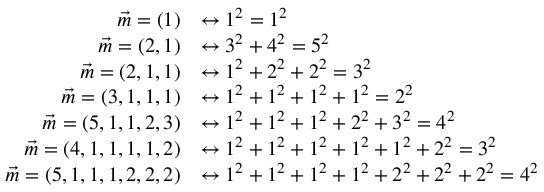Convert formula to latex. <formula><loc_0><loc_0><loc_500><loc_500>{ \begin{array} { r l } { { \vec { m } } = ( 1 ) } & { \leftrightarrow 1 ^ { 2 } = 1 ^ { 2 } } \\ { { \vec { m } } = ( 2 , 1 ) } & { \leftrightarrow 3 ^ { 2 } + 4 ^ { 2 } = 5 ^ { 2 } } \\ { { \vec { m } } = ( 2 , 1 , 1 ) } & { \leftrightarrow 1 ^ { 2 } + 2 ^ { 2 } + 2 ^ { 2 } = 3 ^ { 2 } } \\ { { \vec { m } } = ( 3 , 1 , 1 , 1 ) } & { \leftrightarrow 1 ^ { 2 } + 1 ^ { 2 } + 1 ^ { 2 } + 1 ^ { 2 } = 2 ^ { 2 } } \\ { { \vec { m } } = ( 5 , 1 , 1 , 2 , 3 ) } & { \leftrightarrow 1 ^ { 2 } + 1 ^ { 2 } + 1 ^ { 2 } + 2 ^ { 2 } + 3 ^ { 2 } = 4 ^ { 2 } } \\ { { \vec { m } } = ( 4 , 1 , 1 , 1 , 1 , 2 ) } & { \leftrightarrow 1 ^ { 2 } + 1 ^ { 2 } + 1 ^ { 2 } + 1 ^ { 2 } + 1 ^ { 2 } + 2 ^ { 2 } = 3 ^ { 2 } } \\ { { \vec { m } } = ( 5 , 1 , 1 , 1 , 2 , 2 , 2 ) } & { \leftrightarrow 1 ^ { 2 } + 1 ^ { 2 } + 1 ^ { 2 } + 1 ^ { 2 } + 2 ^ { 2 } + 2 ^ { 2 } + 2 ^ { 2 } = 4 ^ { 2 } } \end{array} }</formula> 